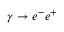Convert formula to latex. <formula><loc_0><loc_0><loc_500><loc_500>\gamma \to e ^ { - } e ^ { + }</formula> 